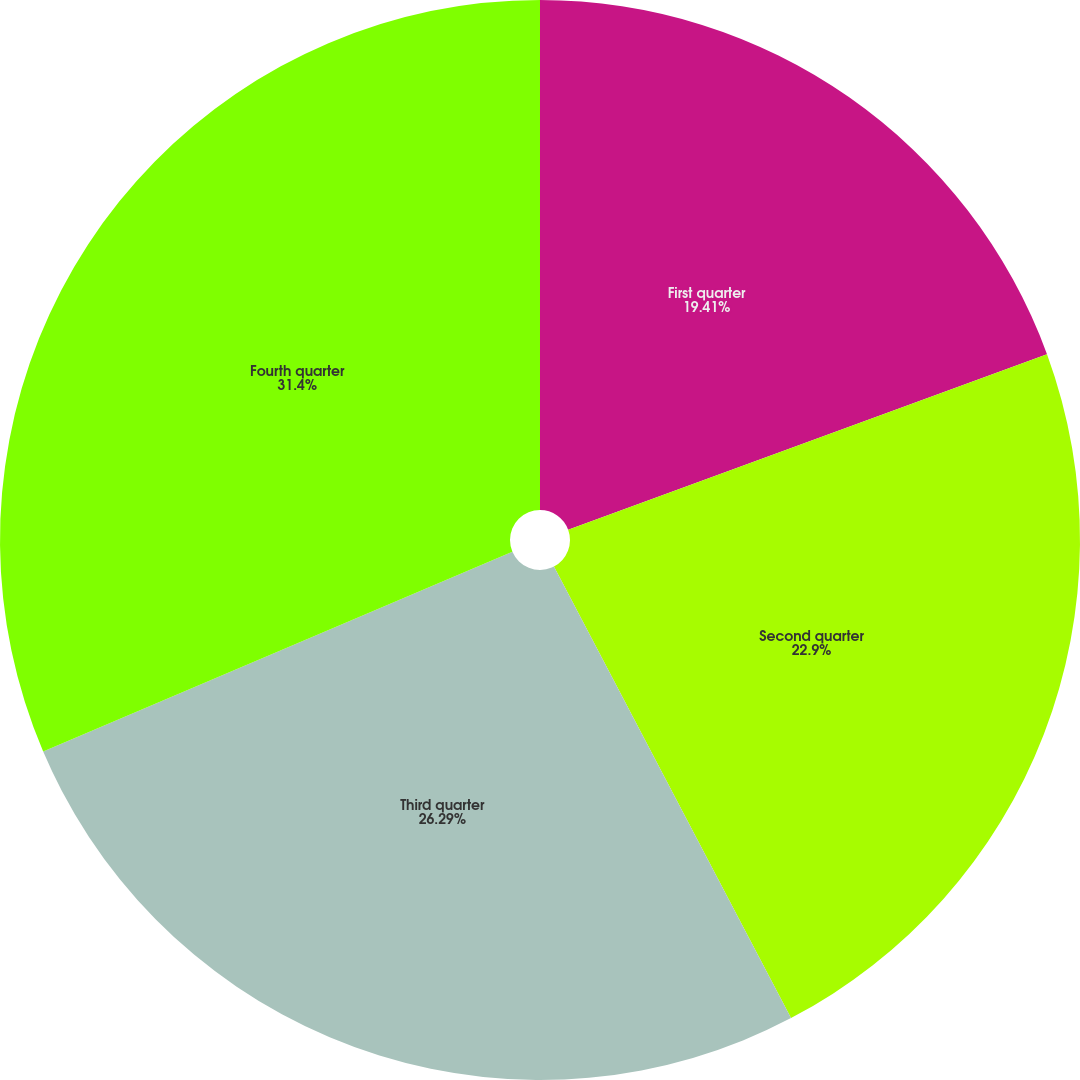<chart> <loc_0><loc_0><loc_500><loc_500><pie_chart><fcel>First quarter<fcel>Second quarter<fcel>Third quarter<fcel>Fourth quarter<nl><fcel>19.41%<fcel>22.9%<fcel>26.29%<fcel>31.41%<nl></chart> 